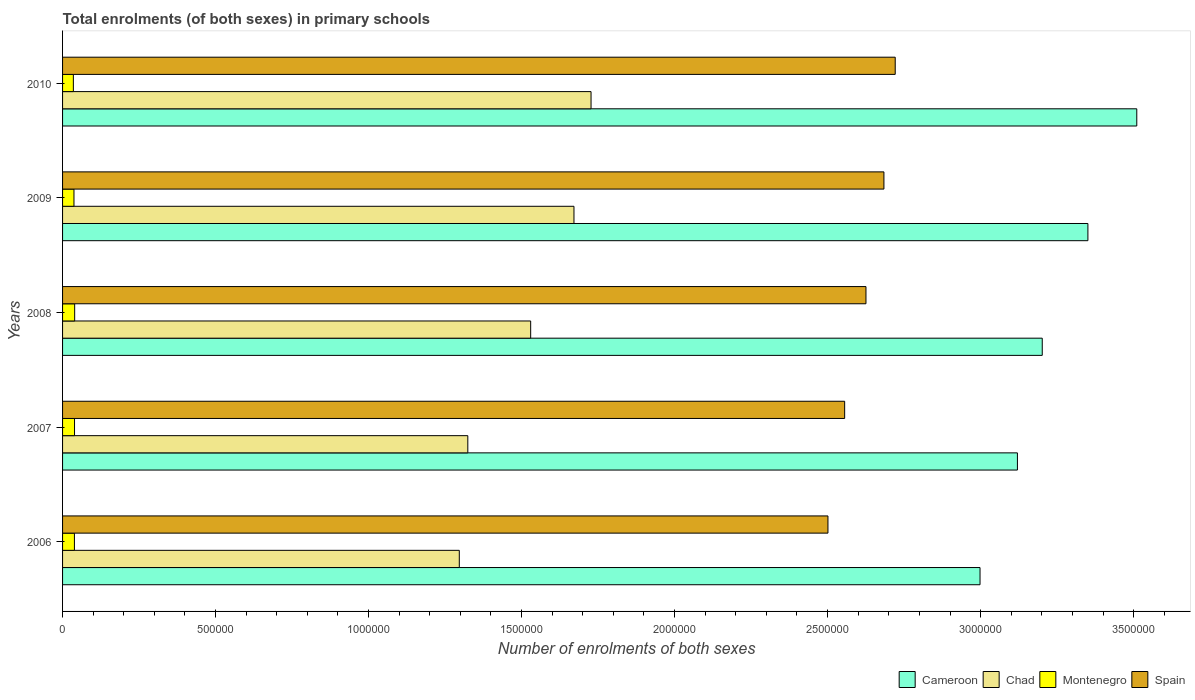How many different coloured bars are there?
Keep it short and to the point. 4. How many groups of bars are there?
Your answer should be very brief. 5. Are the number of bars per tick equal to the number of legend labels?
Make the answer very short. Yes. Are the number of bars on each tick of the Y-axis equal?
Keep it short and to the point. Yes. How many bars are there on the 2nd tick from the top?
Your answer should be compact. 4. What is the number of enrolments in primary schools in Chad in 2006?
Your answer should be very brief. 1.30e+06. Across all years, what is the maximum number of enrolments in primary schools in Cameroon?
Keep it short and to the point. 3.51e+06. Across all years, what is the minimum number of enrolments in primary schools in Spain?
Give a very brief answer. 2.50e+06. In which year was the number of enrolments in primary schools in Montenegro maximum?
Your answer should be compact. 2008. What is the total number of enrolments in primary schools in Cameroon in the graph?
Provide a short and direct response. 1.62e+07. What is the difference between the number of enrolments in primary schools in Spain in 2007 and that in 2009?
Provide a succinct answer. -1.28e+05. What is the difference between the number of enrolments in primary schools in Spain in 2010 and the number of enrolments in primary schools in Montenegro in 2007?
Offer a very short reply. 2.68e+06. What is the average number of enrolments in primary schools in Chad per year?
Make the answer very short. 1.51e+06. In the year 2009, what is the difference between the number of enrolments in primary schools in Montenegro and number of enrolments in primary schools in Chad?
Give a very brief answer. -1.63e+06. What is the ratio of the number of enrolments in primary schools in Chad in 2007 to that in 2010?
Your response must be concise. 0.77. Is the number of enrolments in primary schools in Spain in 2008 less than that in 2009?
Provide a short and direct response. Yes. What is the difference between the highest and the second highest number of enrolments in primary schools in Chad?
Your answer should be very brief. 5.58e+04. What is the difference between the highest and the lowest number of enrolments in primary schools in Cameroon?
Your answer should be very brief. 5.12e+05. Is the sum of the number of enrolments in primary schools in Montenegro in 2006 and 2009 greater than the maximum number of enrolments in primary schools in Spain across all years?
Ensure brevity in your answer.  No. Is it the case that in every year, the sum of the number of enrolments in primary schools in Spain and number of enrolments in primary schools in Cameroon is greater than the sum of number of enrolments in primary schools in Chad and number of enrolments in primary schools in Montenegro?
Make the answer very short. Yes. What does the 4th bar from the bottom in 2007 represents?
Your response must be concise. Spain. Is it the case that in every year, the sum of the number of enrolments in primary schools in Montenegro and number of enrolments in primary schools in Cameroon is greater than the number of enrolments in primary schools in Chad?
Offer a very short reply. Yes. How many bars are there?
Offer a terse response. 20. How many years are there in the graph?
Your answer should be compact. 5. Does the graph contain any zero values?
Make the answer very short. No. How many legend labels are there?
Ensure brevity in your answer.  4. How are the legend labels stacked?
Provide a short and direct response. Horizontal. What is the title of the graph?
Offer a very short reply. Total enrolments (of both sexes) in primary schools. Does "Nicaragua" appear as one of the legend labels in the graph?
Offer a very short reply. No. What is the label or title of the X-axis?
Provide a short and direct response. Number of enrolments of both sexes. What is the label or title of the Y-axis?
Your response must be concise. Years. What is the Number of enrolments of both sexes in Cameroon in 2006?
Give a very brief answer. 3.00e+06. What is the Number of enrolments of both sexes of Chad in 2006?
Give a very brief answer. 1.30e+06. What is the Number of enrolments of both sexes in Montenegro in 2006?
Provide a succinct answer. 3.87e+04. What is the Number of enrolments of both sexes of Spain in 2006?
Keep it short and to the point. 2.50e+06. What is the Number of enrolments of both sexes in Cameroon in 2007?
Your answer should be compact. 3.12e+06. What is the Number of enrolments of both sexes of Chad in 2007?
Make the answer very short. 1.32e+06. What is the Number of enrolments of both sexes in Montenegro in 2007?
Your answer should be compact. 3.91e+04. What is the Number of enrolments of both sexes of Spain in 2007?
Your answer should be very brief. 2.56e+06. What is the Number of enrolments of both sexes of Cameroon in 2008?
Your answer should be compact. 3.20e+06. What is the Number of enrolments of both sexes of Chad in 2008?
Provide a succinct answer. 1.53e+06. What is the Number of enrolments of both sexes in Montenegro in 2008?
Keep it short and to the point. 3.96e+04. What is the Number of enrolments of both sexes of Spain in 2008?
Offer a very short reply. 2.63e+06. What is the Number of enrolments of both sexes of Cameroon in 2009?
Provide a short and direct response. 3.35e+06. What is the Number of enrolments of both sexes in Chad in 2009?
Ensure brevity in your answer.  1.67e+06. What is the Number of enrolments of both sexes of Montenegro in 2009?
Provide a succinct answer. 3.73e+04. What is the Number of enrolments of both sexes in Spain in 2009?
Keep it short and to the point. 2.68e+06. What is the Number of enrolments of both sexes of Cameroon in 2010?
Provide a short and direct response. 3.51e+06. What is the Number of enrolments of both sexes in Chad in 2010?
Provide a short and direct response. 1.73e+06. What is the Number of enrolments of both sexes in Montenegro in 2010?
Provide a succinct answer. 3.53e+04. What is the Number of enrolments of both sexes of Spain in 2010?
Your answer should be very brief. 2.72e+06. Across all years, what is the maximum Number of enrolments of both sexes in Cameroon?
Offer a very short reply. 3.51e+06. Across all years, what is the maximum Number of enrolments of both sexes of Chad?
Your answer should be compact. 1.73e+06. Across all years, what is the maximum Number of enrolments of both sexes in Montenegro?
Ensure brevity in your answer.  3.96e+04. Across all years, what is the maximum Number of enrolments of both sexes of Spain?
Your answer should be compact. 2.72e+06. Across all years, what is the minimum Number of enrolments of both sexes of Cameroon?
Give a very brief answer. 3.00e+06. Across all years, what is the minimum Number of enrolments of both sexes in Chad?
Ensure brevity in your answer.  1.30e+06. Across all years, what is the minimum Number of enrolments of both sexes in Montenegro?
Give a very brief answer. 3.53e+04. Across all years, what is the minimum Number of enrolments of both sexes of Spain?
Your response must be concise. 2.50e+06. What is the total Number of enrolments of both sexes of Cameroon in the graph?
Your answer should be very brief. 1.62e+07. What is the total Number of enrolments of both sexes in Chad in the graph?
Offer a terse response. 7.55e+06. What is the total Number of enrolments of both sexes of Montenegro in the graph?
Offer a terse response. 1.90e+05. What is the total Number of enrolments of both sexes of Spain in the graph?
Provide a succinct answer. 1.31e+07. What is the difference between the Number of enrolments of both sexes in Cameroon in 2006 and that in 2007?
Provide a short and direct response. -1.22e+05. What is the difference between the Number of enrolments of both sexes of Chad in 2006 and that in 2007?
Give a very brief answer. -2.78e+04. What is the difference between the Number of enrolments of both sexes in Montenegro in 2006 and that in 2007?
Offer a very short reply. -383. What is the difference between the Number of enrolments of both sexes in Spain in 2006 and that in 2007?
Keep it short and to the point. -5.46e+04. What is the difference between the Number of enrolments of both sexes of Cameroon in 2006 and that in 2008?
Provide a succinct answer. -2.03e+05. What is the difference between the Number of enrolments of both sexes of Chad in 2006 and that in 2008?
Make the answer very short. -2.33e+05. What is the difference between the Number of enrolments of both sexes of Montenegro in 2006 and that in 2008?
Your response must be concise. -840. What is the difference between the Number of enrolments of both sexes in Spain in 2006 and that in 2008?
Your answer should be very brief. -1.24e+05. What is the difference between the Number of enrolments of both sexes in Cameroon in 2006 and that in 2009?
Offer a terse response. -3.53e+05. What is the difference between the Number of enrolments of both sexes of Chad in 2006 and that in 2009?
Your answer should be compact. -3.75e+05. What is the difference between the Number of enrolments of both sexes of Montenegro in 2006 and that in 2009?
Offer a terse response. 1471. What is the difference between the Number of enrolments of both sexes of Spain in 2006 and that in 2009?
Offer a very short reply. -1.83e+05. What is the difference between the Number of enrolments of both sexes of Cameroon in 2006 and that in 2010?
Your answer should be compact. -5.12e+05. What is the difference between the Number of enrolments of both sexes of Chad in 2006 and that in 2010?
Keep it short and to the point. -4.31e+05. What is the difference between the Number of enrolments of both sexes in Montenegro in 2006 and that in 2010?
Ensure brevity in your answer.  3476. What is the difference between the Number of enrolments of both sexes in Spain in 2006 and that in 2010?
Ensure brevity in your answer.  -2.20e+05. What is the difference between the Number of enrolments of both sexes of Cameroon in 2007 and that in 2008?
Offer a terse response. -8.11e+04. What is the difference between the Number of enrolments of both sexes in Chad in 2007 and that in 2008?
Offer a terse response. -2.05e+05. What is the difference between the Number of enrolments of both sexes of Montenegro in 2007 and that in 2008?
Ensure brevity in your answer.  -457. What is the difference between the Number of enrolments of both sexes of Spain in 2007 and that in 2008?
Provide a short and direct response. -6.97e+04. What is the difference between the Number of enrolments of both sexes of Cameroon in 2007 and that in 2009?
Offer a very short reply. -2.30e+05. What is the difference between the Number of enrolments of both sexes in Chad in 2007 and that in 2009?
Make the answer very short. -3.47e+05. What is the difference between the Number of enrolments of both sexes of Montenegro in 2007 and that in 2009?
Provide a succinct answer. 1854. What is the difference between the Number of enrolments of both sexes in Spain in 2007 and that in 2009?
Keep it short and to the point. -1.28e+05. What is the difference between the Number of enrolments of both sexes of Cameroon in 2007 and that in 2010?
Offer a terse response. -3.90e+05. What is the difference between the Number of enrolments of both sexes of Chad in 2007 and that in 2010?
Offer a very short reply. -4.03e+05. What is the difference between the Number of enrolments of both sexes of Montenegro in 2007 and that in 2010?
Give a very brief answer. 3859. What is the difference between the Number of enrolments of both sexes of Spain in 2007 and that in 2010?
Provide a succinct answer. -1.65e+05. What is the difference between the Number of enrolments of both sexes of Cameroon in 2008 and that in 2009?
Ensure brevity in your answer.  -1.49e+05. What is the difference between the Number of enrolments of both sexes in Chad in 2008 and that in 2009?
Your response must be concise. -1.41e+05. What is the difference between the Number of enrolments of both sexes of Montenegro in 2008 and that in 2009?
Make the answer very short. 2311. What is the difference between the Number of enrolments of both sexes of Spain in 2008 and that in 2009?
Your answer should be compact. -5.87e+04. What is the difference between the Number of enrolments of both sexes of Cameroon in 2008 and that in 2010?
Offer a very short reply. -3.09e+05. What is the difference between the Number of enrolments of both sexes in Chad in 2008 and that in 2010?
Offer a very short reply. -1.97e+05. What is the difference between the Number of enrolments of both sexes of Montenegro in 2008 and that in 2010?
Offer a very short reply. 4316. What is the difference between the Number of enrolments of both sexes of Spain in 2008 and that in 2010?
Keep it short and to the point. -9.56e+04. What is the difference between the Number of enrolments of both sexes in Cameroon in 2009 and that in 2010?
Provide a succinct answer. -1.60e+05. What is the difference between the Number of enrolments of both sexes of Chad in 2009 and that in 2010?
Offer a very short reply. -5.58e+04. What is the difference between the Number of enrolments of both sexes of Montenegro in 2009 and that in 2010?
Keep it short and to the point. 2005. What is the difference between the Number of enrolments of both sexes of Spain in 2009 and that in 2010?
Your answer should be compact. -3.69e+04. What is the difference between the Number of enrolments of both sexes in Cameroon in 2006 and the Number of enrolments of both sexes in Chad in 2007?
Your response must be concise. 1.67e+06. What is the difference between the Number of enrolments of both sexes in Cameroon in 2006 and the Number of enrolments of both sexes in Montenegro in 2007?
Your response must be concise. 2.96e+06. What is the difference between the Number of enrolments of both sexes of Cameroon in 2006 and the Number of enrolments of both sexes of Spain in 2007?
Make the answer very short. 4.42e+05. What is the difference between the Number of enrolments of both sexes in Chad in 2006 and the Number of enrolments of both sexes in Montenegro in 2007?
Your response must be concise. 1.26e+06. What is the difference between the Number of enrolments of both sexes in Chad in 2006 and the Number of enrolments of both sexes in Spain in 2007?
Offer a very short reply. -1.26e+06. What is the difference between the Number of enrolments of both sexes of Montenegro in 2006 and the Number of enrolments of both sexes of Spain in 2007?
Offer a very short reply. -2.52e+06. What is the difference between the Number of enrolments of both sexes in Cameroon in 2006 and the Number of enrolments of both sexes in Chad in 2008?
Make the answer very short. 1.47e+06. What is the difference between the Number of enrolments of both sexes of Cameroon in 2006 and the Number of enrolments of both sexes of Montenegro in 2008?
Your response must be concise. 2.96e+06. What is the difference between the Number of enrolments of both sexes of Cameroon in 2006 and the Number of enrolments of both sexes of Spain in 2008?
Offer a terse response. 3.73e+05. What is the difference between the Number of enrolments of both sexes in Chad in 2006 and the Number of enrolments of both sexes in Montenegro in 2008?
Make the answer very short. 1.26e+06. What is the difference between the Number of enrolments of both sexes of Chad in 2006 and the Number of enrolments of both sexes of Spain in 2008?
Make the answer very short. -1.33e+06. What is the difference between the Number of enrolments of both sexes in Montenegro in 2006 and the Number of enrolments of both sexes in Spain in 2008?
Your answer should be very brief. -2.59e+06. What is the difference between the Number of enrolments of both sexes of Cameroon in 2006 and the Number of enrolments of both sexes of Chad in 2009?
Your answer should be compact. 1.33e+06. What is the difference between the Number of enrolments of both sexes of Cameroon in 2006 and the Number of enrolments of both sexes of Montenegro in 2009?
Offer a terse response. 2.96e+06. What is the difference between the Number of enrolments of both sexes of Cameroon in 2006 and the Number of enrolments of both sexes of Spain in 2009?
Your response must be concise. 3.14e+05. What is the difference between the Number of enrolments of both sexes of Chad in 2006 and the Number of enrolments of both sexes of Montenegro in 2009?
Your response must be concise. 1.26e+06. What is the difference between the Number of enrolments of both sexes of Chad in 2006 and the Number of enrolments of both sexes of Spain in 2009?
Provide a succinct answer. -1.39e+06. What is the difference between the Number of enrolments of both sexes in Montenegro in 2006 and the Number of enrolments of both sexes in Spain in 2009?
Make the answer very short. -2.65e+06. What is the difference between the Number of enrolments of both sexes in Cameroon in 2006 and the Number of enrolments of both sexes in Chad in 2010?
Provide a short and direct response. 1.27e+06. What is the difference between the Number of enrolments of both sexes in Cameroon in 2006 and the Number of enrolments of both sexes in Montenegro in 2010?
Your answer should be very brief. 2.96e+06. What is the difference between the Number of enrolments of both sexes in Cameroon in 2006 and the Number of enrolments of both sexes in Spain in 2010?
Provide a succinct answer. 2.77e+05. What is the difference between the Number of enrolments of both sexes of Chad in 2006 and the Number of enrolments of both sexes of Montenegro in 2010?
Provide a succinct answer. 1.26e+06. What is the difference between the Number of enrolments of both sexes in Chad in 2006 and the Number of enrolments of both sexes in Spain in 2010?
Offer a terse response. -1.42e+06. What is the difference between the Number of enrolments of both sexes in Montenegro in 2006 and the Number of enrolments of both sexes in Spain in 2010?
Keep it short and to the point. -2.68e+06. What is the difference between the Number of enrolments of both sexes of Cameroon in 2007 and the Number of enrolments of both sexes of Chad in 2008?
Your answer should be compact. 1.59e+06. What is the difference between the Number of enrolments of both sexes in Cameroon in 2007 and the Number of enrolments of both sexes in Montenegro in 2008?
Keep it short and to the point. 3.08e+06. What is the difference between the Number of enrolments of both sexes of Cameroon in 2007 and the Number of enrolments of both sexes of Spain in 2008?
Your response must be concise. 4.95e+05. What is the difference between the Number of enrolments of both sexes of Chad in 2007 and the Number of enrolments of both sexes of Montenegro in 2008?
Offer a very short reply. 1.28e+06. What is the difference between the Number of enrolments of both sexes of Chad in 2007 and the Number of enrolments of both sexes of Spain in 2008?
Offer a very short reply. -1.30e+06. What is the difference between the Number of enrolments of both sexes in Montenegro in 2007 and the Number of enrolments of both sexes in Spain in 2008?
Ensure brevity in your answer.  -2.59e+06. What is the difference between the Number of enrolments of both sexes of Cameroon in 2007 and the Number of enrolments of both sexes of Chad in 2009?
Your response must be concise. 1.45e+06. What is the difference between the Number of enrolments of both sexes in Cameroon in 2007 and the Number of enrolments of both sexes in Montenegro in 2009?
Offer a very short reply. 3.08e+06. What is the difference between the Number of enrolments of both sexes of Cameroon in 2007 and the Number of enrolments of both sexes of Spain in 2009?
Provide a succinct answer. 4.36e+05. What is the difference between the Number of enrolments of both sexes of Chad in 2007 and the Number of enrolments of both sexes of Montenegro in 2009?
Your response must be concise. 1.29e+06. What is the difference between the Number of enrolments of both sexes in Chad in 2007 and the Number of enrolments of both sexes in Spain in 2009?
Your answer should be compact. -1.36e+06. What is the difference between the Number of enrolments of both sexes of Montenegro in 2007 and the Number of enrolments of both sexes of Spain in 2009?
Your answer should be very brief. -2.64e+06. What is the difference between the Number of enrolments of both sexes of Cameroon in 2007 and the Number of enrolments of both sexes of Chad in 2010?
Your response must be concise. 1.39e+06. What is the difference between the Number of enrolments of both sexes in Cameroon in 2007 and the Number of enrolments of both sexes in Montenegro in 2010?
Offer a terse response. 3.09e+06. What is the difference between the Number of enrolments of both sexes in Cameroon in 2007 and the Number of enrolments of both sexes in Spain in 2010?
Provide a succinct answer. 3.99e+05. What is the difference between the Number of enrolments of both sexes of Chad in 2007 and the Number of enrolments of both sexes of Montenegro in 2010?
Make the answer very short. 1.29e+06. What is the difference between the Number of enrolments of both sexes of Chad in 2007 and the Number of enrolments of both sexes of Spain in 2010?
Offer a very short reply. -1.40e+06. What is the difference between the Number of enrolments of both sexes of Montenegro in 2007 and the Number of enrolments of both sexes of Spain in 2010?
Make the answer very short. -2.68e+06. What is the difference between the Number of enrolments of both sexes of Cameroon in 2008 and the Number of enrolments of both sexes of Chad in 2009?
Offer a very short reply. 1.53e+06. What is the difference between the Number of enrolments of both sexes of Cameroon in 2008 and the Number of enrolments of both sexes of Montenegro in 2009?
Give a very brief answer. 3.16e+06. What is the difference between the Number of enrolments of both sexes of Cameroon in 2008 and the Number of enrolments of both sexes of Spain in 2009?
Ensure brevity in your answer.  5.17e+05. What is the difference between the Number of enrolments of both sexes in Chad in 2008 and the Number of enrolments of both sexes in Montenegro in 2009?
Provide a succinct answer. 1.49e+06. What is the difference between the Number of enrolments of both sexes in Chad in 2008 and the Number of enrolments of both sexes in Spain in 2009?
Your response must be concise. -1.15e+06. What is the difference between the Number of enrolments of both sexes of Montenegro in 2008 and the Number of enrolments of both sexes of Spain in 2009?
Offer a terse response. -2.64e+06. What is the difference between the Number of enrolments of both sexes of Cameroon in 2008 and the Number of enrolments of both sexes of Chad in 2010?
Make the answer very short. 1.47e+06. What is the difference between the Number of enrolments of both sexes of Cameroon in 2008 and the Number of enrolments of both sexes of Montenegro in 2010?
Ensure brevity in your answer.  3.17e+06. What is the difference between the Number of enrolments of both sexes in Cameroon in 2008 and the Number of enrolments of both sexes in Spain in 2010?
Give a very brief answer. 4.80e+05. What is the difference between the Number of enrolments of both sexes of Chad in 2008 and the Number of enrolments of both sexes of Montenegro in 2010?
Give a very brief answer. 1.49e+06. What is the difference between the Number of enrolments of both sexes of Chad in 2008 and the Number of enrolments of both sexes of Spain in 2010?
Offer a very short reply. -1.19e+06. What is the difference between the Number of enrolments of both sexes in Montenegro in 2008 and the Number of enrolments of both sexes in Spain in 2010?
Make the answer very short. -2.68e+06. What is the difference between the Number of enrolments of both sexes in Cameroon in 2009 and the Number of enrolments of both sexes in Chad in 2010?
Keep it short and to the point. 1.62e+06. What is the difference between the Number of enrolments of both sexes in Cameroon in 2009 and the Number of enrolments of both sexes in Montenegro in 2010?
Offer a terse response. 3.32e+06. What is the difference between the Number of enrolments of both sexes in Cameroon in 2009 and the Number of enrolments of both sexes in Spain in 2010?
Offer a very short reply. 6.30e+05. What is the difference between the Number of enrolments of both sexes in Chad in 2009 and the Number of enrolments of both sexes in Montenegro in 2010?
Offer a very short reply. 1.64e+06. What is the difference between the Number of enrolments of both sexes of Chad in 2009 and the Number of enrolments of both sexes of Spain in 2010?
Offer a very short reply. -1.05e+06. What is the difference between the Number of enrolments of both sexes of Montenegro in 2009 and the Number of enrolments of both sexes of Spain in 2010?
Keep it short and to the point. -2.68e+06. What is the average Number of enrolments of both sexes in Cameroon per year?
Give a very brief answer. 3.24e+06. What is the average Number of enrolments of both sexes of Chad per year?
Provide a succinct answer. 1.51e+06. What is the average Number of enrolments of both sexes in Montenegro per year?
Make the answer very short. 3.80e+04. What is the average Number of enrolments of both sexes of Spain per year?
Keep it short and to the point. 2.62e+06. In the year 2006, what is the difference between the Number of enrolments of both sexes in Cameroon and Number of enrolments of both sexes in Chad?
Offer a terse response. 1.70e+06. In the year 2006, what is the difference between the Number of enrolments of both sexes in Cameroon and Number of enrolments of both sexes in Montenegro?
Offer a terse response. 2.96e+06. In the year 2006, what is the difference between the Number of enrolments of both sexes of Cameroon and Number of enrolments of both sexes of Spain?
Keep it short and to the point. 4.97e+05. In the year 2006, what is the difference between the Number of enrolments of both sexes of Chad and Number of enrolments of both sexes of Montenegro?
Make the answer very short. 1.26e+06. In the year 2006, what is the difference between the Number of enrolments of both sexes in Chad and Number of enrolments of both sexes in Spain?
Provide a succinct answer. -1.20e+06. In the year 2006, what is the difference between the Number of enrolments of both sexes of Montenegro and Number of enrolments of both sexes of Spain?
Offer a very short reply. -2.46e+06. In the year 2007, what is the difference between the Number of enrolments of both sexes of Cameroon and Number of enrolments of both sexes of Chad?
Your answer should be compact. 1.80e+06. In the year 2007, what is the difference between the Number of enrolments of both sexes in Cameroon and Number of enrolments of both sexes in Montenegro?
Your response must be concise. 3.08e+06. In the year 2007, what is the difference between the Number of enrolments of both sexes of Cameroon and Number of enrolments of both sexes of Spain?
Give a very brief answer. 5.65e+05. In the year 2007, what is the difference between the Number of enrolments of both sexes in Chad and Number of enrolments of both sexes in Montenegro?
Ensure brevity in your answer.  1.29e+06. In the year 2007, what is the difference between the Number of enrolments of both sexes of Chad and Number of enrolments of both sexes of Spain?
Your answer should be compact. -1.23e+06. In the year 2007, what is the difference between the Number of enrolments of both sexes of Montenegro and Number of enrolments of both sexes of Spain?
Ensure brevity in your answer.  -2.52e+06. In the year 2008, what is the difference between the Number of enrolments of both sexes of Cameroon and Number of enrolments of both sexes of Chad?
Your response must be concise. 1.67e+06. In the year 2008, what is the difference between the Number of enrolments of both sexes of Cameroon and Number of enrolments of both sexes of Montenegro?
Provide a short and direct response. 3.16e+06. In the year 2008, what is the difference between the Number of enrolments of both sexes in Cameroon and Number of enrolments of both sexes in Spain?
Give a very brief answer. 5.76e+05. In the year 2008, what is the difference between the Number of enrolments of both sexes of Chad and Number of enrolments of both sexes of Montenegro?
Your answer should be compact. 1.49e+06. In the year 2008, what is the difference between the Number of enrolments of both sexes in Chad and Number of enrolments of both sexes in Spain?
Your answer should be very brief. -1.10e+06. In the year 2008, what is the difference between the Number of enrolments of both sexes of Montenegro and Number of enrolments of both sexes of Spain?
Keep it short and to the point. -2.59e+06. In the year 2009, what is the difference between the Number of enrolments of both sexes in Cameroon and Number of enrolments of both sexes in Chad?
Ensure brevity in your answer.  1.68e+06. In the year 2009, what is the difference between the Number of enrolments of both sexes of Cameroon and Number of enrolments of both sexes of Montenegro?
Ensure brevity in your answer.  3.31e+06. In the year 2009, what is the difference between the Number of enrolments of both sexes of Cameroon and Number of enrolments of both sexes of Spain?
Offer a terse response. 6.67e+05. In the year 2009, what is the difference between the Number of enrolments of both sexes in Chad and Number of enrolments of both sexes in Montenegro?
Offer a terse response. 1.63e+06. In the year 2009, what is the difference between the Number of enrolments of both sexes in Chad and Number of enrolments of both sexes in Spain?
Ensure brevity in your answer.  -1.01e+06. In the year 2009, what is the difference between the Number of enrolments of both sexes of Montenegro and Number of enrolments of both sexes of Spain?
Your answer should be compact. -2.65e+06. In the year 2010, what is the difference between the Number of enrolments of both sexes in Cameroon and Number of enrolments of both sexes in Chad?
Give a very brief answer. 1.78e+06. In the year 2010, what is the difference between the Number of enrolments of both sexes of Cameroon and Number of enrolments of both sexes of Montenegro?
Ensure brevity in your answer.  3.48e+06. In the year 2010, what is the difference between the Number of enrolments of both sexes of Cameroon and Number of enrolments of both sexes of Spain?
Provide a short and direct response. 7.89e+05. In the year 2010, what is the difference between the Number of enrolments of both sexes in Chad and Number of enrolments of both sexes in Montenegro?
Ensure brevity in your answer.  1.69e+06. In the year 2010, what is the difference between the Number of enrolments of both sexes of Chad and Number of enrolments of both sexes of Spain?
Offer a very short reply. -9.94e+05. In the year 2010, what is the difference between the Number of enrolments of both sexes in Montenegro and Number of enrolments of both sexes in Spain?
Provide a short and direct response. -2.69e+06. What is the ratio of the Number of enrolments of both sexes in Cameroon in 2006 to that in 2007?
Your response must be concise. 0.96. What is the ratio of the Number of enrolments of both sexes in Chad in 2006 to that in 2007?
Give a very brief answer. 0.98. What is the ratio of the Number of enrolments of both sexes of Montenegro in 2006 to that in 2007?
Offer a very short reply. 0.99. What is the ratio of the Number of enrolments of both sexes in Spain in 2006 to that in 2007?
Keep it short and to the point. 0.98. What is the ratio of the Number of enrolments of both sexes in Cameroon in 2006 to that in 2008?
Provide a short and direct response. 0.94. What is the ratio of the Number of enrolments of both sexes in Chad in 2006 to that in 2008?
Your answer should be very brief. 0.85. What is the ratio of the Number of enrolments of both sexes in Montenegro in 2006 to that in 2008?
Your answer should be compact. 0.98. What is the ratio of the Number of enrolments of both sexes in Spain in 2006 to that in 2008?
Keep it short and to the point. 0.95. What is the ratio of the Number of enrolments of both sexes of Cameroon in 2006 to that in 2009?
Ensure brevity in your answer.  0.89. What is the ratio of the Number of enrolments of both sexes in Chad in 2006 to that in 2009?
Give a very brief answer. 0.78. What is the ratio of the Number of enrolments of both sexes of Montenegro in 2006 to that in 2009?
Provide a short and direct response. 1.04. What is the ratio of the Number of enrolments of both sexes in Spain in 2006 to that in 2009?
Give a very brief answer. 0.93. What is the ratio of the Number of enrolments of both sexes of Cameroon in 2006 to that in 2010?
Provide a succinct answer. 0.85. What is the ratio of the Number of enrolments of both sexes of Chad in 2006 to that in 2010?
Your answer should be compact. 0.75. What is the ratio of the Number of enrolments of both sexes in Montenegro in 2006 to that in 2010?
Make the answer very short. 1.1. What is the ratio of the Number of enrolments of both sexes in Spain in 2006 to that in 2010?
Your answer should be very brief. 0.92. What is the ratio of the Number of enrolments of both sexes of Cameroon in 2007 to that in 2008?
Provide a short and direct response. 0.97. What is the ratio of the Number of enrolments of both sexes in Chad in 2007 to that in 2008?
Keep it short and to the point. 0.87. What is the ratio of the Number of enrolments of both sexes of Spain in 2007 to that in 2008?
Offer a very short reply. 0.97. What is the ratio of the Number of enrolments of both sexes in Cameroon in 2007 to that in 2009?
Make the answer very short. 0.93. What is the ratio of the Number of enrolments of both sexes of Chad in 2007 to that in 2009?
Your response must be concise. 0.79. What is the ratio of the Number of enrolments of both sexes in Montenegro in 2007 to that in 2009?
Your answer should be very brief. 1.05. What is the ratio of the Number of enrolments of both sexes of Spain in 2007 to that in 2009?
Provide a short and direct response. 0.95. What is the ratio of the Number of enrolments of both sexes in Cameroon in 2007 to that in 2010?
Give a very brief answer. 0.89. What is the ratio of the Number of enrolments of both sexes in Chad in 2007 to that in 2010?
Your answer should be very brief. 0.77. What is the ratio of the Number of enrolments of both sexes of Montenegro in 2007 to that in 2010?
Provide a succinct answer. 1.11. What is the ratio of the Number of enrolments of both sexes of Spain in 2007 to that in 2010?
Provide a succinct answer. 0.94. What is the ratio of the Number of enrolments of both sexes in Cameroon in 2008 to that in 2009?
Keep it short and to the point. 0.96. What is the ratio of the Number of enrolments of both sexes in Chad in 2008 to that in 2009?
Your response must be concise. 0.92. What is the ratio of the Number of enrolments of both sexes in Montenegro in 2008 to that in 2009?
Offer a very short reply. 1.06. What is the ratio of the Number of enrolments of both sexes in Spain in 2008 to that in 2009?
Give a very brief answer. 0.98. What is the ratio of the Number of enrolments of both sexes of Cameroon in 2008 to that in 2010?
Your response must be concise. 0.91. What is the ratio of the Number of enrolments of both sexes of Chad in 2008 to that in 2010?
Provide a succinct answer. 0.89. What is the ratio of the Number of enrolments of both sexes in Montenegro in 2008 to that in 2010?
Provide a short and direct response. 1.12. What is the ratio of the Number of enrolments of both sexes of Spain in 2008 to that in 2010?
Ensure brevity in your answer.  0.96. What is the ratio of the Number of enrolments of both sexes of Cameroon in 2009 to that in 2010?
Provide a short and direct response. 0.95. What is the ratio of the Number of enrolments of both sexes in Chad in 2009 to that in 2010?
Provide a short and direct response. 0.97. What is the ratio of the Number of enrolments of both sexes of Montenegro in 2009 to that in 2010?
Keep it short and to the point. 1.06. What is the ratio of the Number of enrolments of both sexes of Spain in 2009 to that in 2010?
Ensure brevity in your answer.  0.99. What is the difference between the highest and the second highest Number of enrolments of both sexes of Cameroon?
Provide a short and direct response. 1.60e+05. What is the difference between the highest and the second highest Number of enrolments of both sexes of Chad?
Keep it short and to the point. 5.58e+04. What is the difference between the highest and the second highest Number of enrolments of both sexes of Montenegro?
Provide a succinct answer. 457. What is the difference between the highest and the second highest Number of enrolments of both sexes in Spain?
Offer a very short reply. 3.69e+04. What is the difference between the highest and the lowest Number of enrolments of both sexes in Cameroon?
Make the answer very short. 5.12e+05. What is the difference between the highest and the lowest Number of enrolments of both sexes in Chad?
Offer a very short reply. 4.31e+05. What is the difference between the highest and the lowest Number of enrolments of both sexes of Montenegro?
Keep it short and to the point. 4316. What is the difference between the highest and the lowest Number of enrolments of both sexes in Spain?
Give a very brief answer. 2.20e+05. 